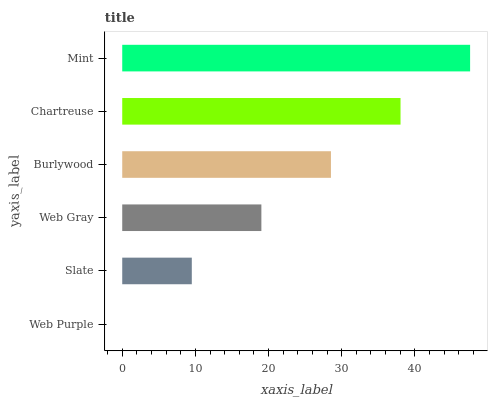Is Web Purple the minimum?
Answer yes or no. Yes. Is Mint the maximum?
Answer yes or no. Yes. Is Slate the minimum?
Answer yes or no. No. Is Slate the maximum?
Answer yes or no. No. Is Slate greater than Web Purple?
Answer yes or no. Yes. Is Web Purple less than Slate?
Answer yes or no. Yes. Is Web Purple greater than Slate?
Answer yes or no. No. Is Slate less than Web Purple?
Answer yes or no. No. Is Burlywood the high median?
Answer yes or no. Yes. Is Web Gray the low median?
Answer yes or no. Yes. Is Web Gray the high median?
Answer yes or no. No. Is Burlywood the low median?
Answer yes or no. No. 